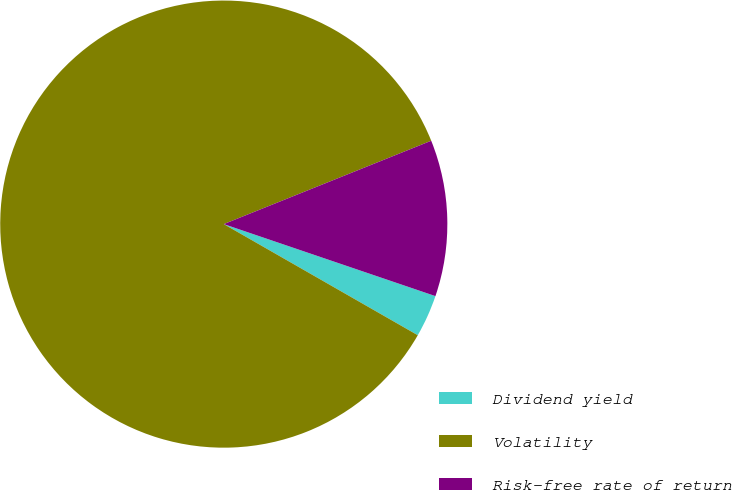<chart> <loc_0><loc_0><loc_500><loc_500><pie_chart><fcel>Dividend yield<fcel>Volatility<fcel>Risk-free rate of return<nl><fcel>3.06%<fcel>85.64%<fcel>11.3%<nl></chart> 